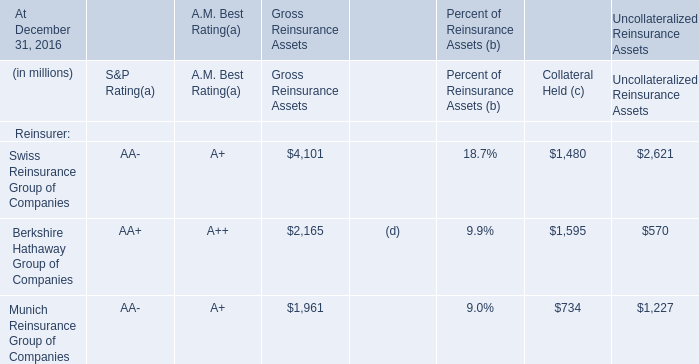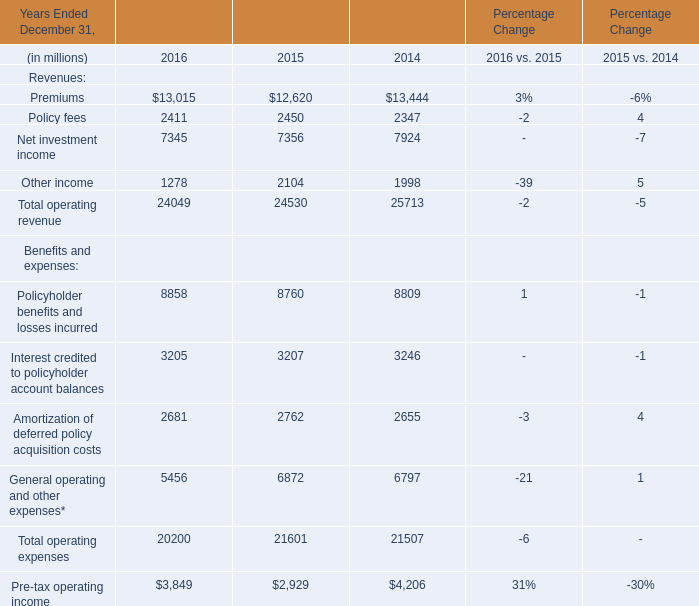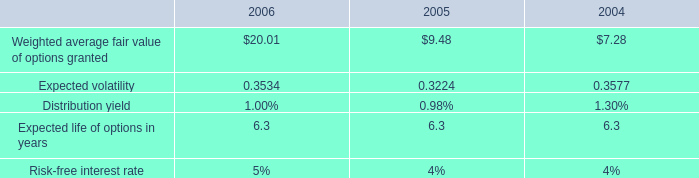What's the sum of Net investment income of Percentage Change 2014, and Munich Reinsurance Group of Companies of Uncollateralized Reinsurance Assets ? 
Computations: (7924.0 + 1227.0)
Answer: 9151.0. 